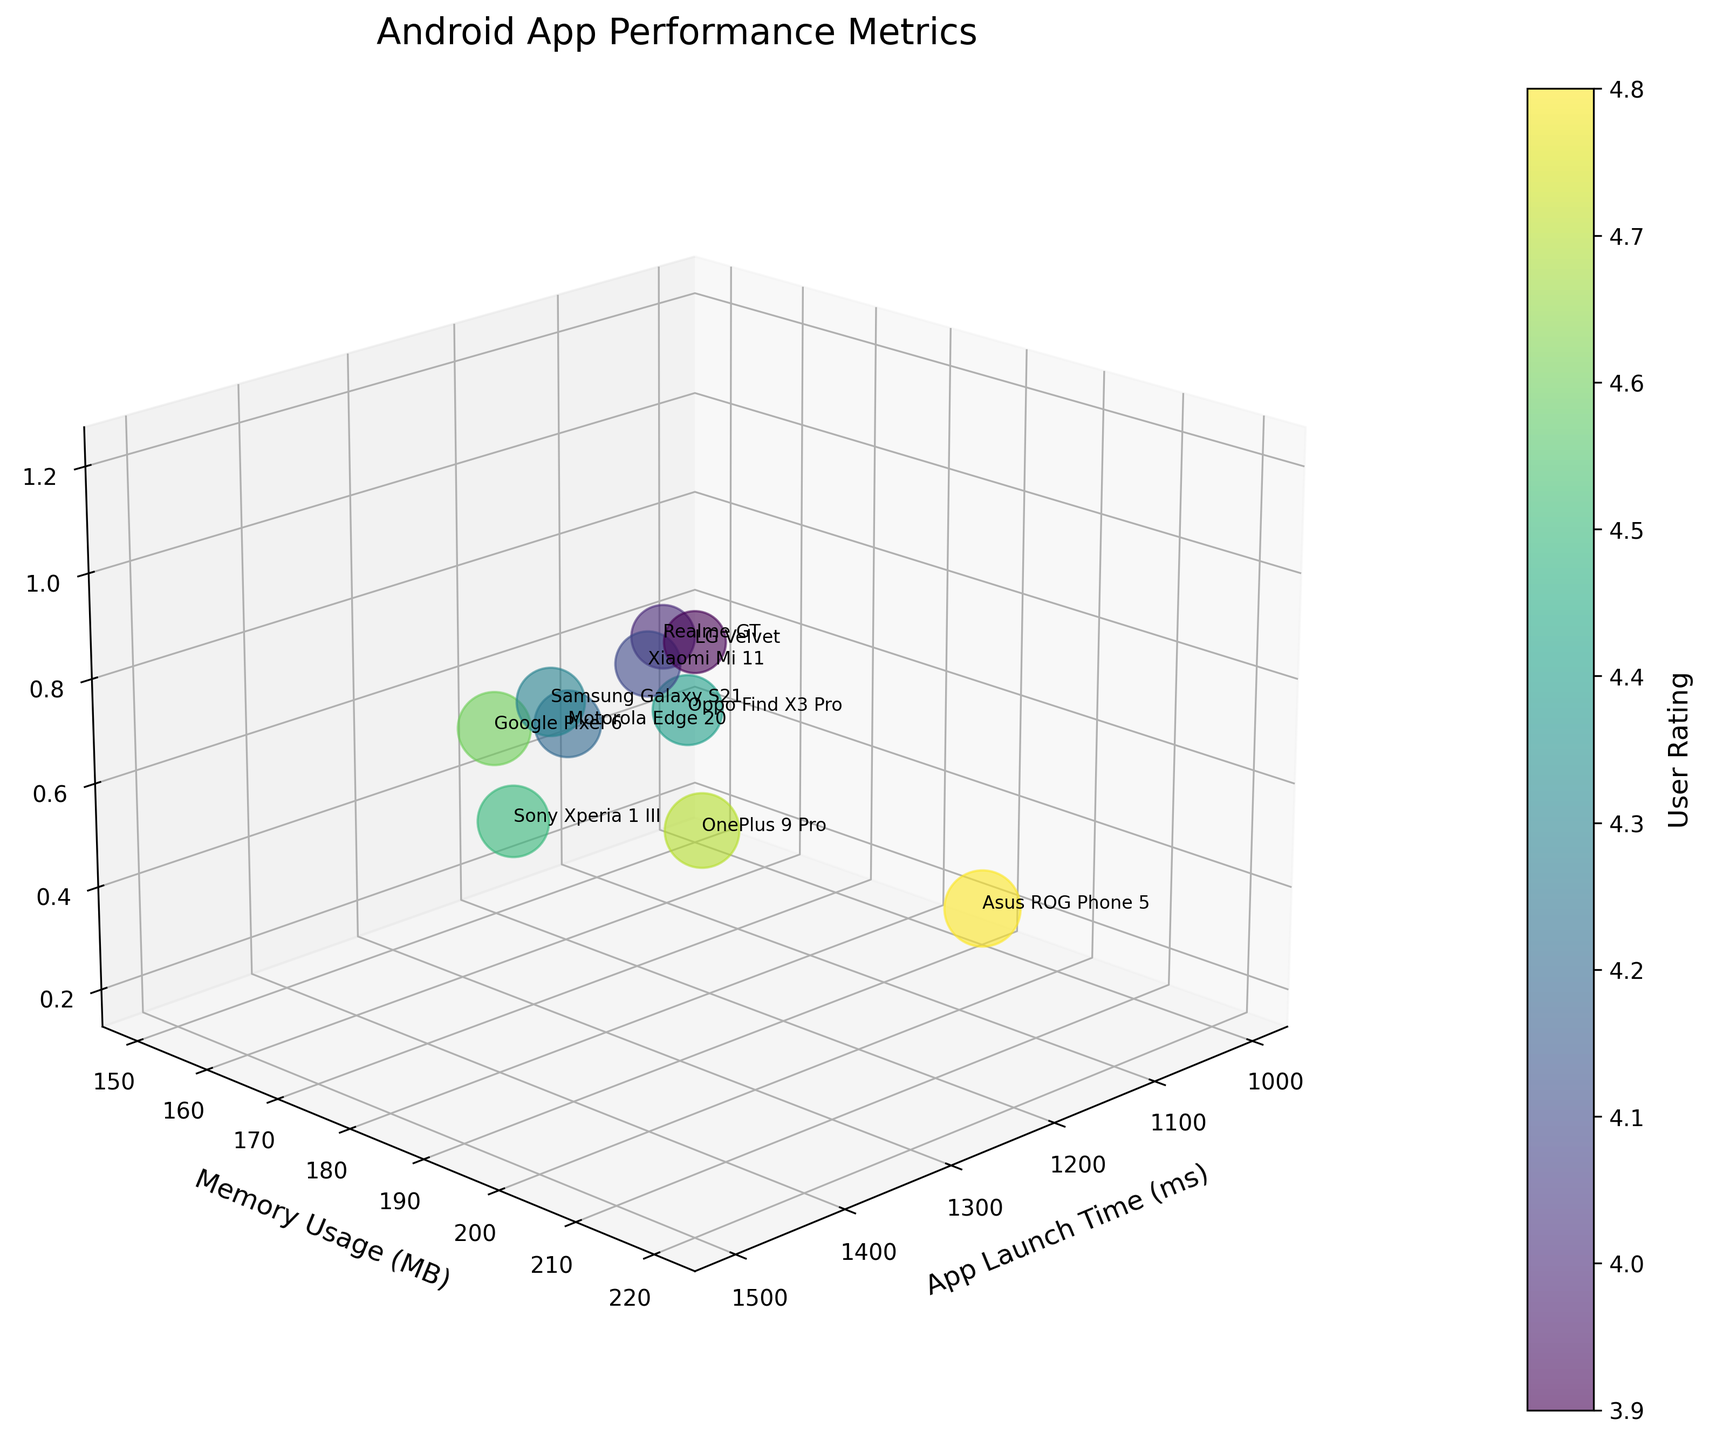What is the title of the chart? The title is prominently displayed at the top of the chart and provides a summary of what the chart is about. Look for large font text dedicated to summarizing the chart.
Answer: Android App Performance Metrics What does the color of the bubbles represent? The color of the bubbles is indicated by the color bar on the side, which shows it represents the User Rating. We can see it transitioning from one color to another along the scale marked with the User Rating.
Answer: User Rating Which device has the highest memory usage? Locate the point on the Memory Usage axis that is farthest from the origin. Then, check the label next to that bubble. According to the data, it is LG Velvet.
Answer: LG Velvet Which app has the lowest crash rate? Locate the point on the Crash Rate axis that is closest to the origin. Then, check the label next to that bubble. According to the data, it is Asus ROG Phone 5.
Answer: Asus ROG Phone 5 What are the axes labels? Axes labels are directly attached to the axes and provide descriptions for the dimensions represented. Check the x, y, and z axes for the labels. They are 'App Launch Time (ms)', 'Memory Usage (MB)', and 'Crash Rate (%)'.
Answer: 'App Launch Time (ms)', 'Memory Usage (MB)', 'Crash Rate (%)' Compare the app launch time between Google Pixel 6 and Asus ROG Phone 5. Find the labeled bubbles for Google Pixel 6 and Asus ROG Phone 5 on the chart and compare their positions on the App Launch Time axis. Google Pixel 6 has a higher launch time compared to Asus ROG Phone 5.
Answer: Google Pixel 6 has a higher launch time What is the median value of the User Rating? Arrange the User Ratings in ascending order and find the middle value. The sorted User Ratings are: 3.9, 4.0, 4.1, 4.2, 4.3, 4.4, 4.5, 4.6, 4.7, 4.8. The median value is the middle number in this list.
Answer: 4.4 Which device model has the largest bubble size and what does it indicate? The largest bubble size represents the highest User Rating because bubble size is determined by User Rating squared. Check for the largest bubble and its label, which is Asus ROG Phone 5.
Answer: Asus ROG Phone 5; highest User Rating 4.8 